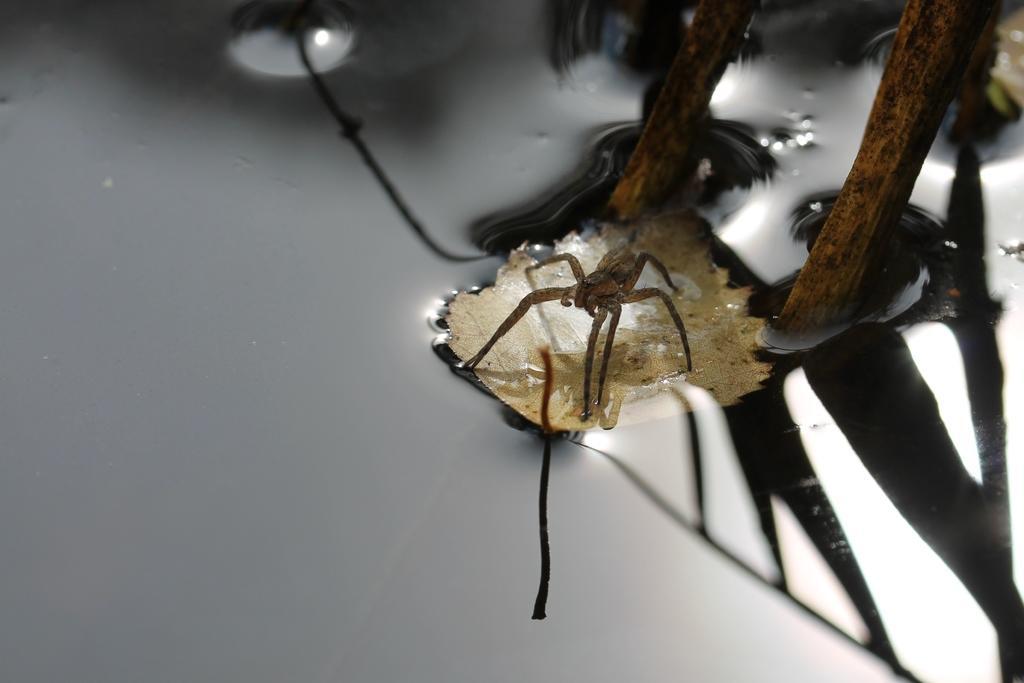Could you give a brief overview of what you see in this image? In this picture I can observe an insect in the middle of the picture. This insect is on the leaf which is floating on the water. 